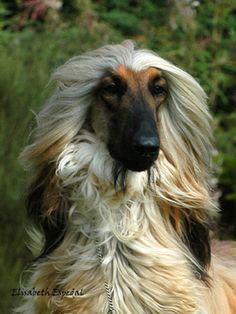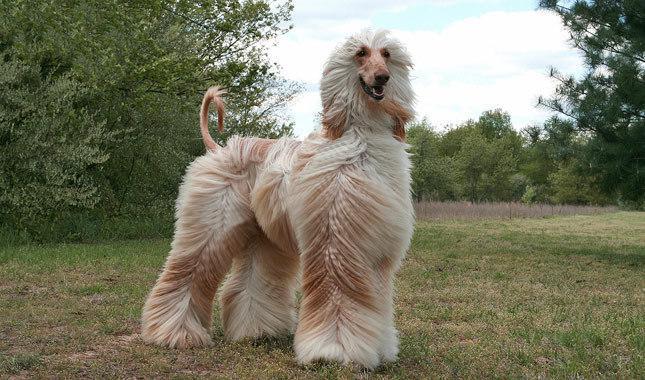The first image is the image on the left, the second image is the image on the right. Given the left and right images, does the statement "There are no fewer than 3 dogs." hold true? Answer yes or no. No. The first image is the image on the left, the second image is the image on the right. Assess this claim about the two images: "The right and left image contains the same number of dogs.". Correct or not? Answer yes or no. Yes. 